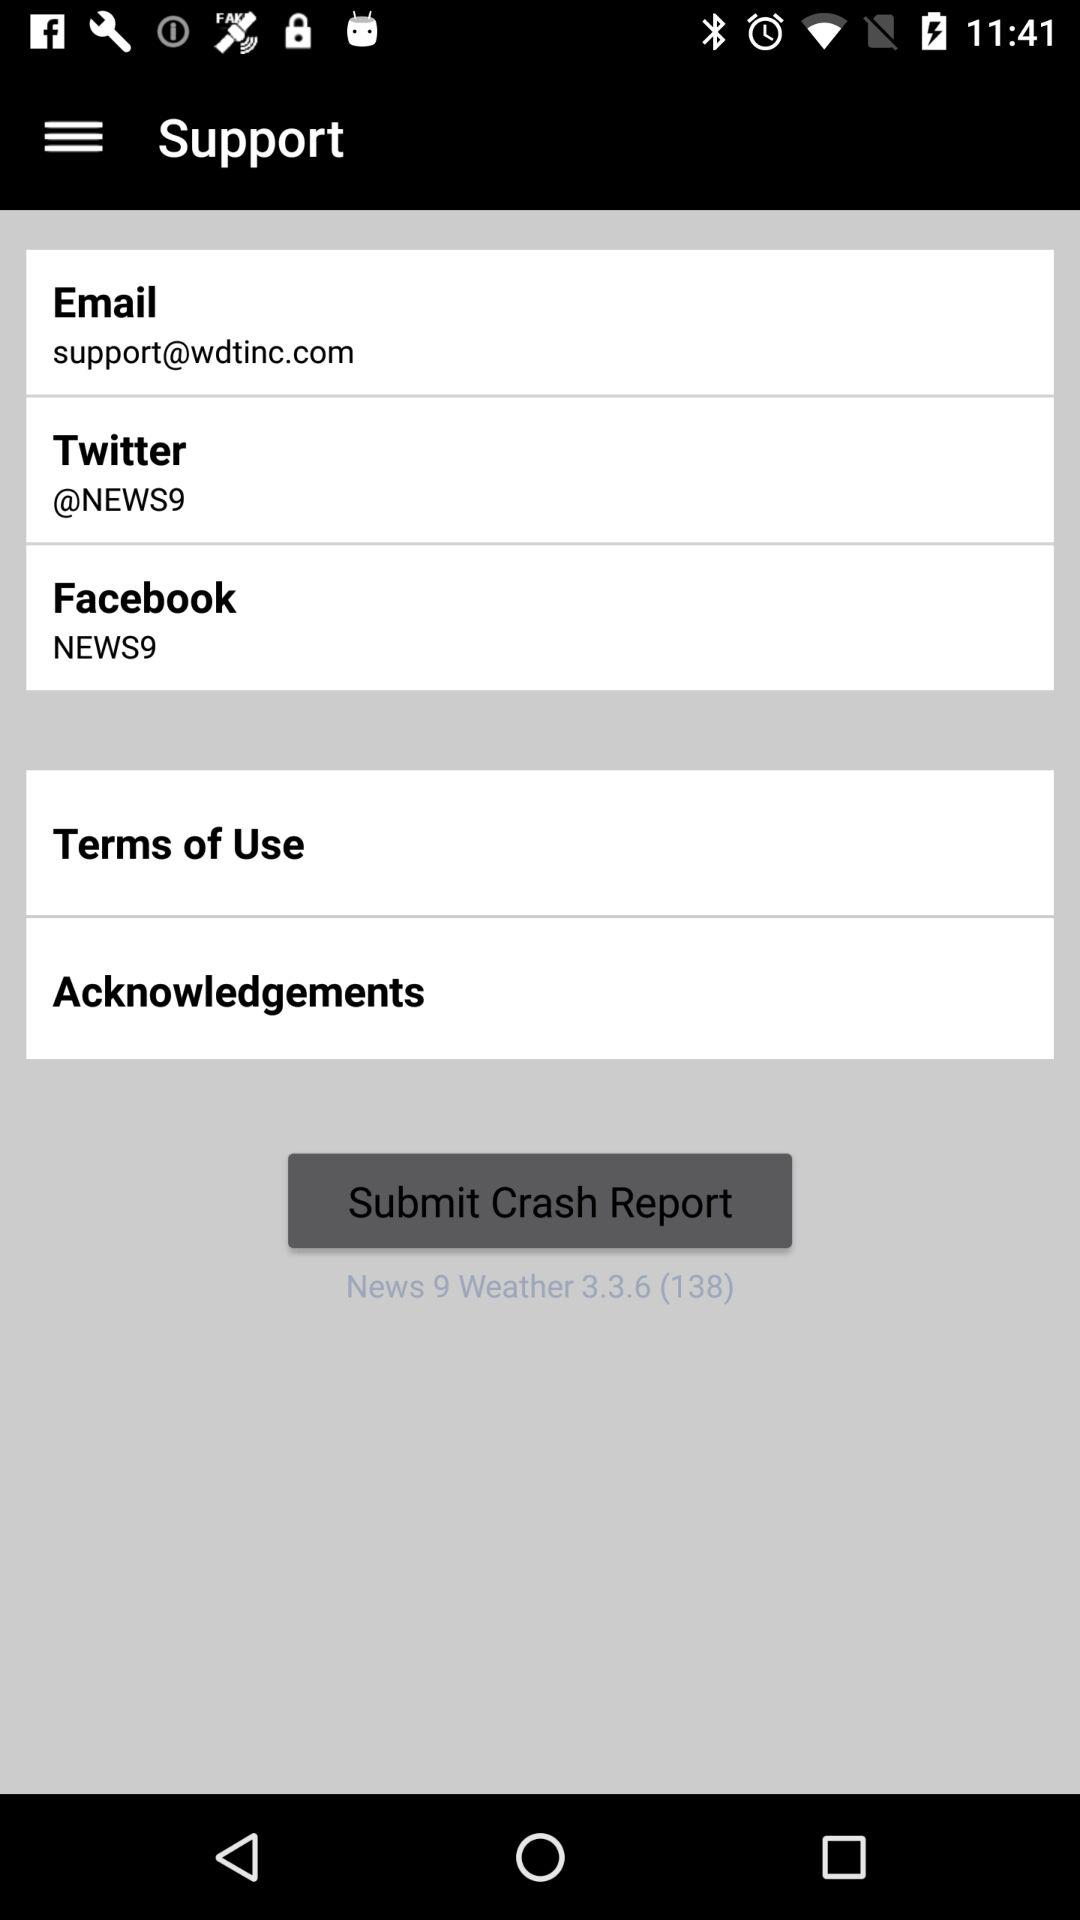What is the Twitter ID? The Twitter ID is "@NEWS9". 